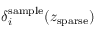Convert formula to latex. <formula><loc_0><loc_0><loc_500><loc_500>\delta _ { i } ^ { s a m p l e } ( z _ { s p a r s e } )</formula> 